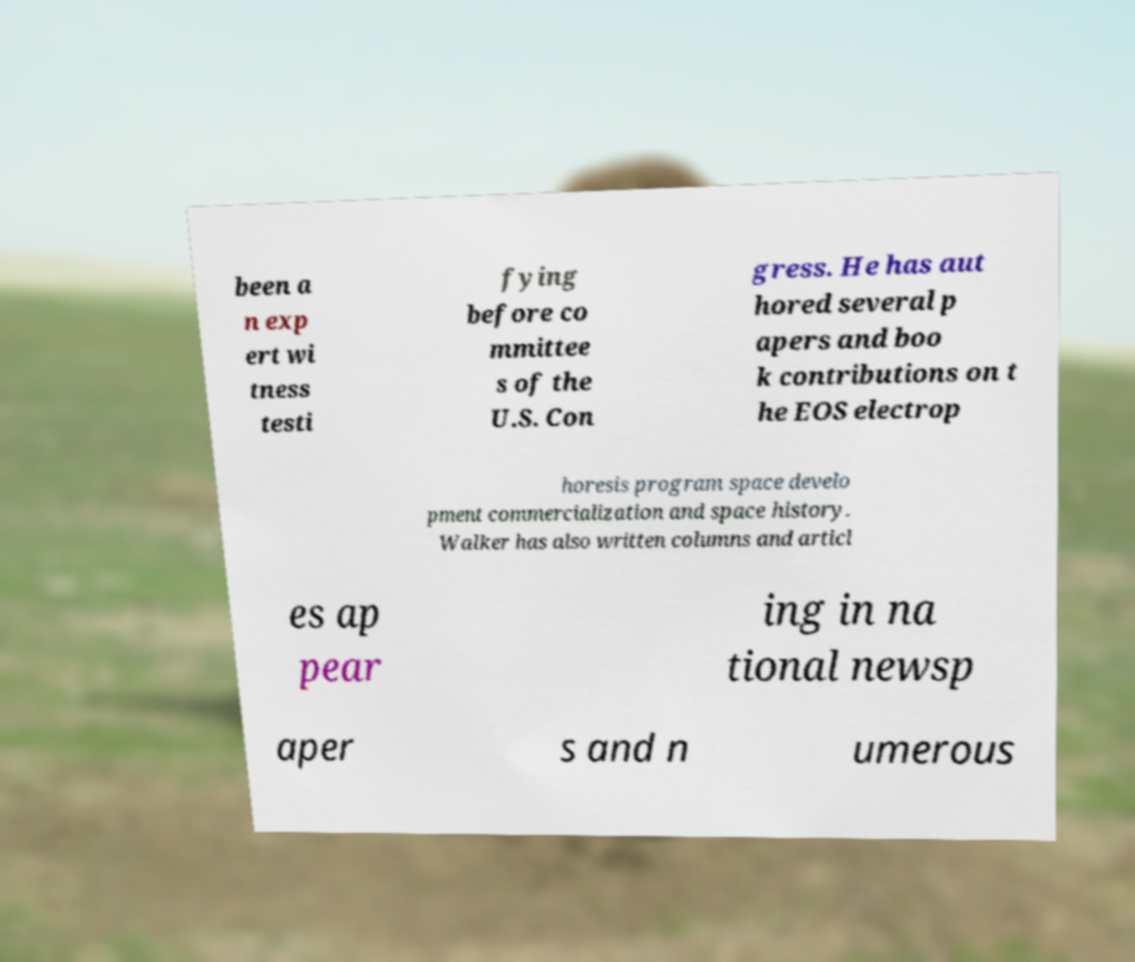Could you assist in decoding the text presented in this image and type it out clearly? been a n exp ert wi tness testi fying before co mmittee s of the U.S. Con gress. He has aut hored several p apers and boo k contributions on t he EOS electrop horesis program space develo pment commercialization and space history. Walker has also written columns and articl es ap pear ing in na tional newsp aper s and n umerous 